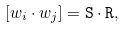<formula> <loc_0><loc_0><loc_500><loc_500>[ w _ { i } \cdot w _ { j } ] = \tt S \cdot \tt R ,</formula> 